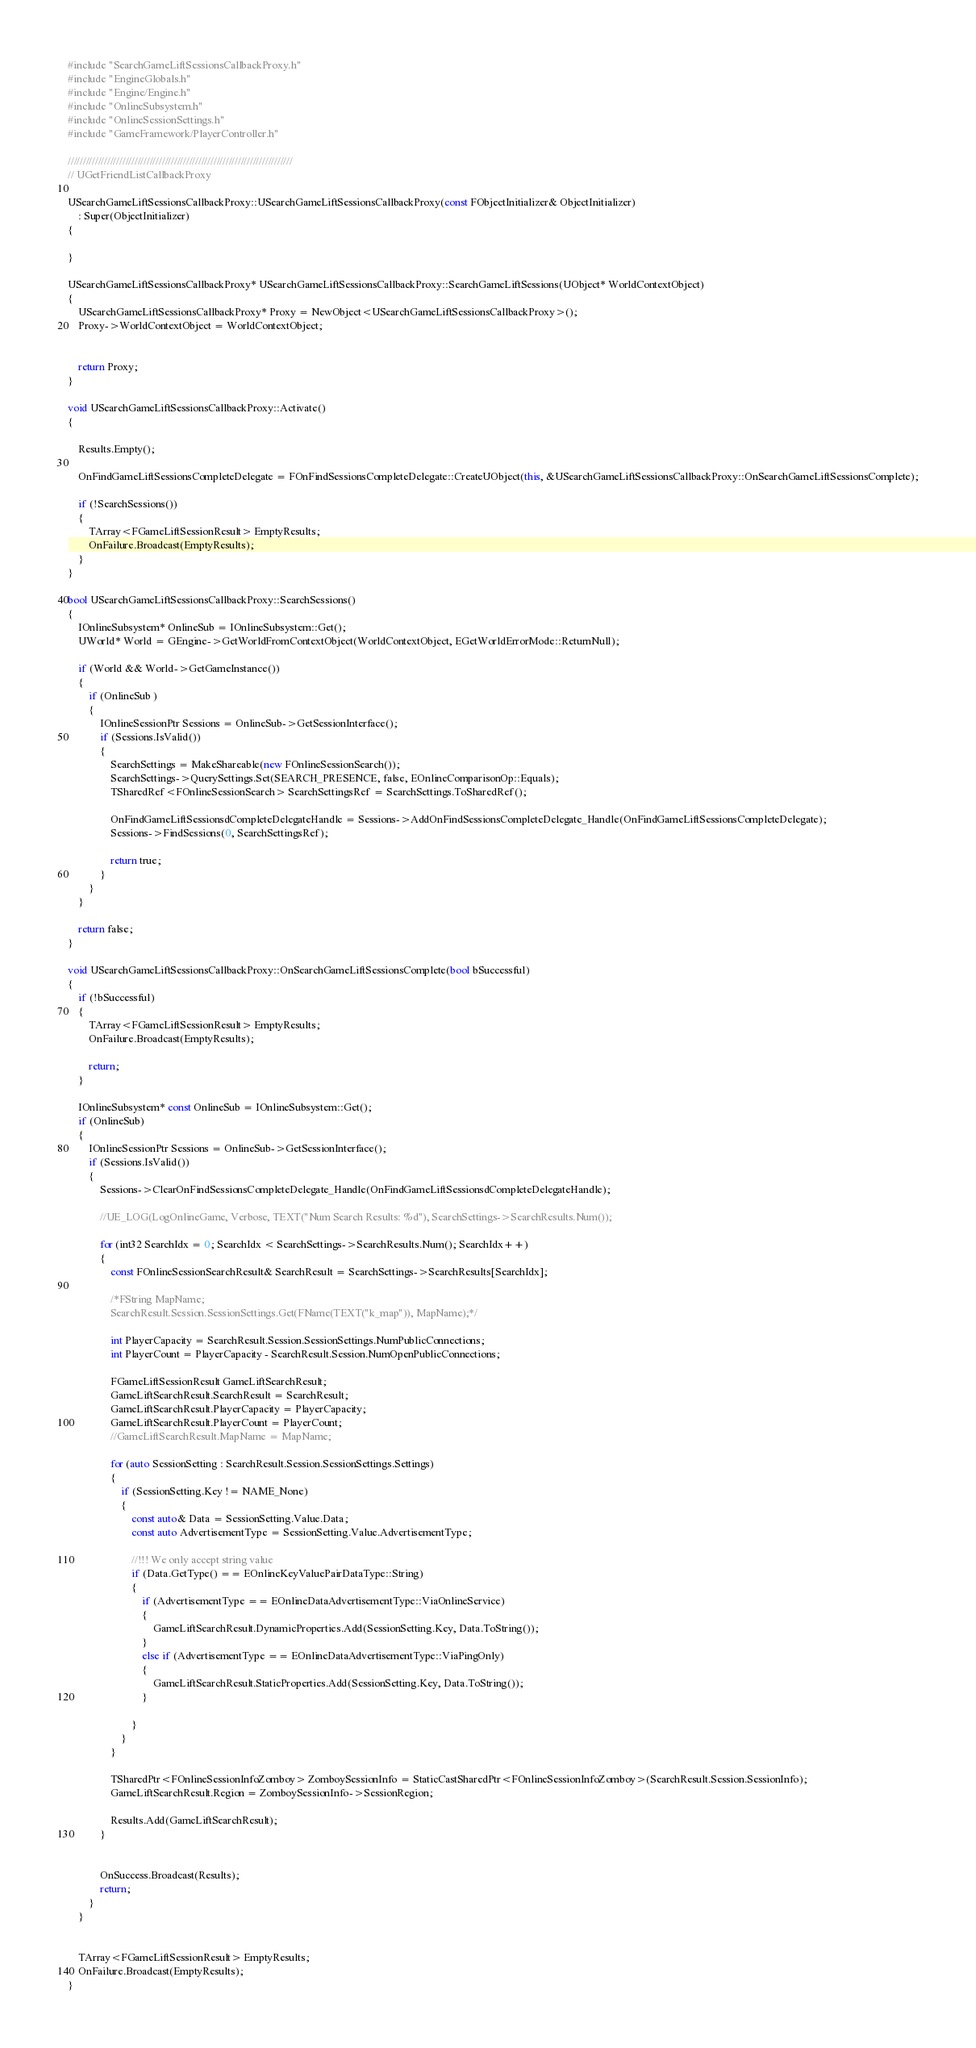<code> <loc_0><loc_0><loc_500><loc_500><_C++_>#include "SearchGameLiftSessionsCallbackProxy.h"
#include "EngineGlobals.h"
#include "Engine/Engine.h"
#include "OnlineSubsystem.h"
#include "OnlineSessionSettings.h"
#include "GameFramework/PlayerController.h"

//////////////////////////////////////////////////////////////////////////
// UGetFriendListCallbackProxy

USearchGameLiftSessionsCallbackProxy::USearchGameLiftSessionsCallbackProxy(const FObjectInitializer& ObjectInitializer)
	: Super(ObjectInitializer)
{

}

USearchGameLiftSessionsCallbackProxy* USearchGameLiftSessionsCallbackProxy::SearchGameLiftSessions(UObject* WorldContextObject)
{
	USearchGameLiftSessionsCallbackProxy* Proxy = NewObject<USearchGameLiftSessionsCallbackProxy>();
	Proxy->WorldContextObject = WorldContextObject;


	return Proxy;
}

void USearchGameLiftSessionsCallbackProxy::Activate()
{

	Results.Empty();

	OnFindGameLiftSessionsCompleteDelegate = FOnFindSessionsCompleteDelegate::CreateUObject(this, &USearchGameLiftSessionsCallbackProxy::OnSearchGameLiftSessionsComplete);

	if (!SearchSessions())
	{
		TArray<FGameLiftSessionResult> EmptyResults;
		OnFailure.Broadcast(EmptyResults);
	}
}

bool USearchGameLiftSessionsCallbackProxy::SearchSessions()
{
	IOnlineSubsystem* OnlineSub = IOnlineSubsystem::Get();
	UWorld* World = GEngine->GetWorldFromContextObject(WorldContextObject, EGetWorldErrorMode::ReturnNull);

	if (World && World->GetGameInstance())
	{
		if (OnlineSub )
		{
			IOnlineSessionPtr Sessions = OnlineSub->GetSessionInterface();
			if (Sessions.IsValid())
			{
				SearchSettings = MakeShareable(new FOnlineSessionSearch());
				SearchSettings->QuerySettings.Set(SEARCH_PRESENCE, false, EOnlineComparisonOp::Equals);
				TSharedRef<FOnlineSessionSearch> SearchSettingsRef = SearchSettings.ToSharedRef();

				OnFindGameLiftSessionsdCompleteDelegateHandle = Sessions->AddOnFindSessionsCompleteDelegate_Handle(OnFindGameLiftSessionsCompleteDelegate);
				Sessions->FindSessions(0, SearchSettingsRef);

				return true;
			}
		}
	}

	return false;
}

void USearchGameLiftSessionsCallbackProxy::OnSearchGameLiftSessionsComplete(bool bSuccessful)
{	
	if (!bSuccessful)
	{
		TArray<FGameLiftSessionResult> EmptyResults;
		OnFailure.Broadcast(EmptyResults);

		return;
	}

	IOnlineSubsystem* const OnlineSub = IOnlineSubsystem::Get();
	if (OnlineSub)
	{
		IOnlineSessionPtr Sessions = OnlineSub->GetSessionInterface();
		if (Sessions.IsValid())
		{
			Sessions->ClearOnFindSessionsCompleteDelegate_Handle(OnFindGameLiftSessionsdCompleteDelegateHandle);

			//UE_LOG(LogOnlineGame, Verbose, TEXT("Num Search Results: %d"), SearchSettings->SearchResults.Num());

			for (int32 SearchIdx = 0; SearchIdx < SearchSettings->SearchResults.Num(); SearchIdx++)
			{
				const FOnlineSessionSearchResult& SearchResult = SearchSettings->SearchResults[SearchIdx];

				/*FString MapName;
				SearchResult.Session.SessionSettings.Get(FName(TEXT("k_map")), MapName);*/

				int PlayerCapacity = SearchResult.Session.SessionSettings.NumPublicConnections;
				int PlayerCount = PlayerCapacity - SearchResult.Session.NumOpenPublicConnections;

				FGameLiftSessionResult GameLiftSearchResult;
				GameLiftSearchResult.SearchResult = SearchResult;
				GameLiftSearchResult.PlayerCapacity = PlayerCapacity;
				GameLiftSearchResult.PlayerCount = PlayerCount;
				//GameLiftSearchResult.MapName = MapName;

				for (auto SessionSetting : SearchResult.Session.SessionSettings.Settings)
				{
					if (SessionSetting.Key != NAME_None)
					{
						const auto& Data = SessionSetting.Value.Data;
						const auto AdvertisementType = SessionSetting.Value.AdvertisementType;

						//!!! We only accept string value
						if (Data.GetType() == EOnlineKeyValuePairDataType::String)
						{
							if (AdvertisementType == EOnlineDataAdvertisementType::ViaOnlineService)
							{
								GameLiftSearchResult.DynamicProperties.Add(SessionSetting.Key, Data.ToString());
							}
							else if (AdvertisementType == EOnlineDataAdvertisementType::ViaPingOnly)
							{
								GameLiftSearchResult.StaticProperties.Add(SessionSetting.Key, Data.ToString());
							}

						}
					}
				}

				TSharedPtr<FOnlineSessionInfoZomboy> ZomboySessionInfo = StaticCastSharedPtr<FOnlineSessionInfoZomboy>(SearchResult.Session.SessionInfo);
				GameLiftSearchResult.Region = ZomboySessionInfo->SessionRegion;
				
				Results.Add(GameLiftSearchResult);
			}

			
			OnSuccess.Broadcast(Results);
			return;
		}
	}

	
	TArray<FGameLiftSessionResult> EmptyResults;
	OnFailure.Broadcast(EmptyResults);
}
</code> 